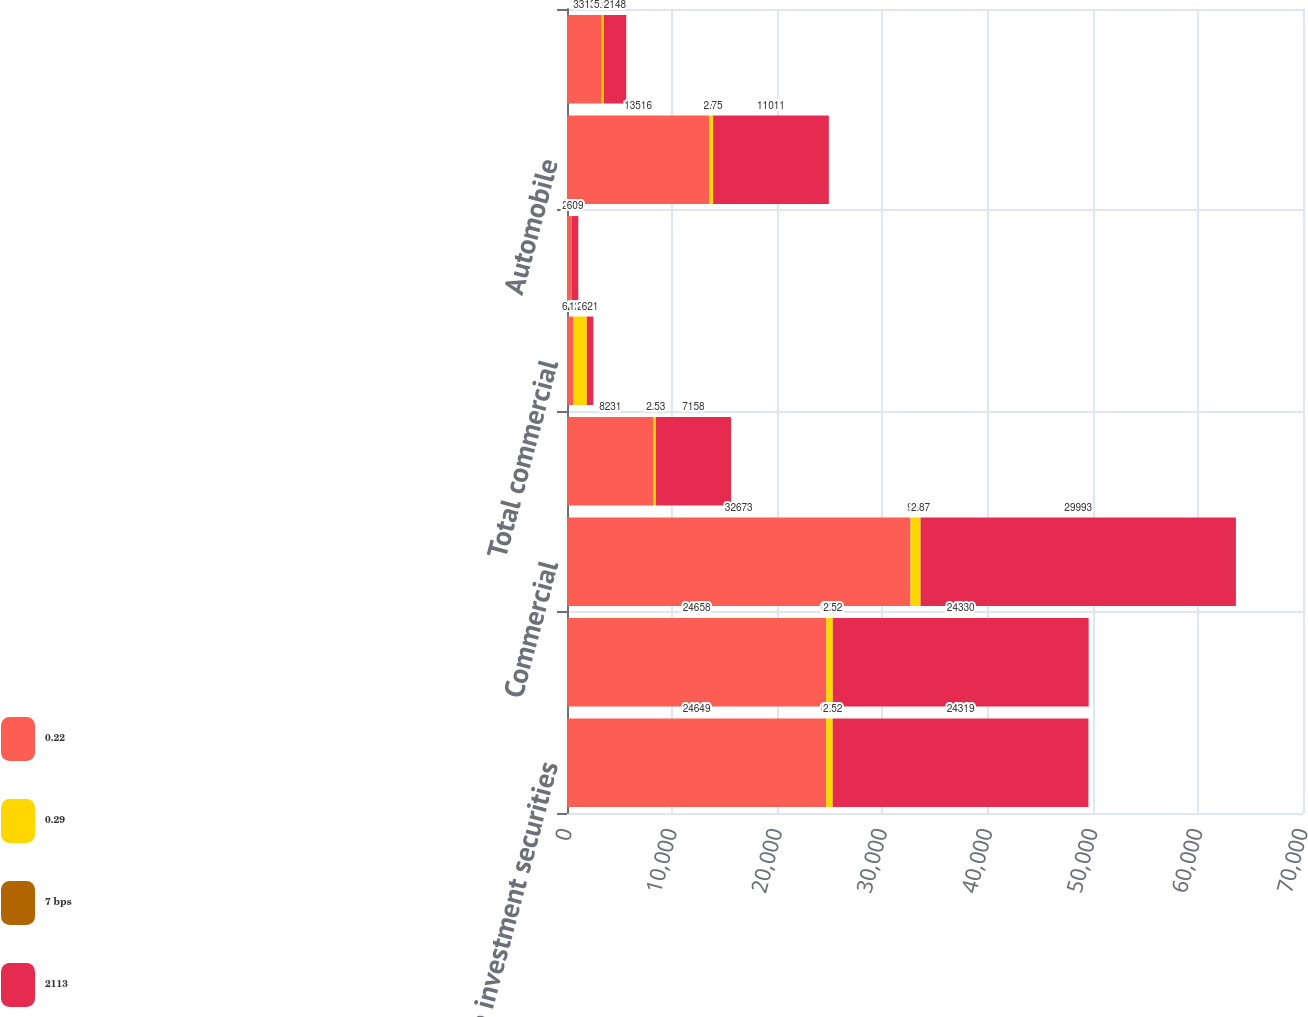Convert chart. <chart><loc_0><loc_0><loc_500><loc_500><stacked_bar_chart><ecel><fcel>Taxable investment securities<fcel>Total investment securities<fcel>Commercial<fcel>Commercial real estate<fcel>Total commercial<fcel>Home equity lines of credit<fcel>Automobile<fcel>Student<nl><fcel>0.22<fcel>24649<fcel>24658<fcel>32673<fcel>8231<fcel>621<fcel>453<fcel>13516<fcel>3313<nl><fcel>0.29<fcel>621<fcel>621<fcel>951<fcel>211<fcel>1259<fcel>11<fcel>372<fcel>167<nl><fcel>7 bps<fcel>2.52<fcel>2.52<fcel>2.87<fcel>2.53<fcel>2.78<fcel>2.44<fcel>2.75<fcel>5.03<nl><fcel>2113<fcel>24319<fcel>24330<fcel>29993<fcel>7158<fcel>621<fcel>609<fcel>11011<fcel>2148<nl></chart> 